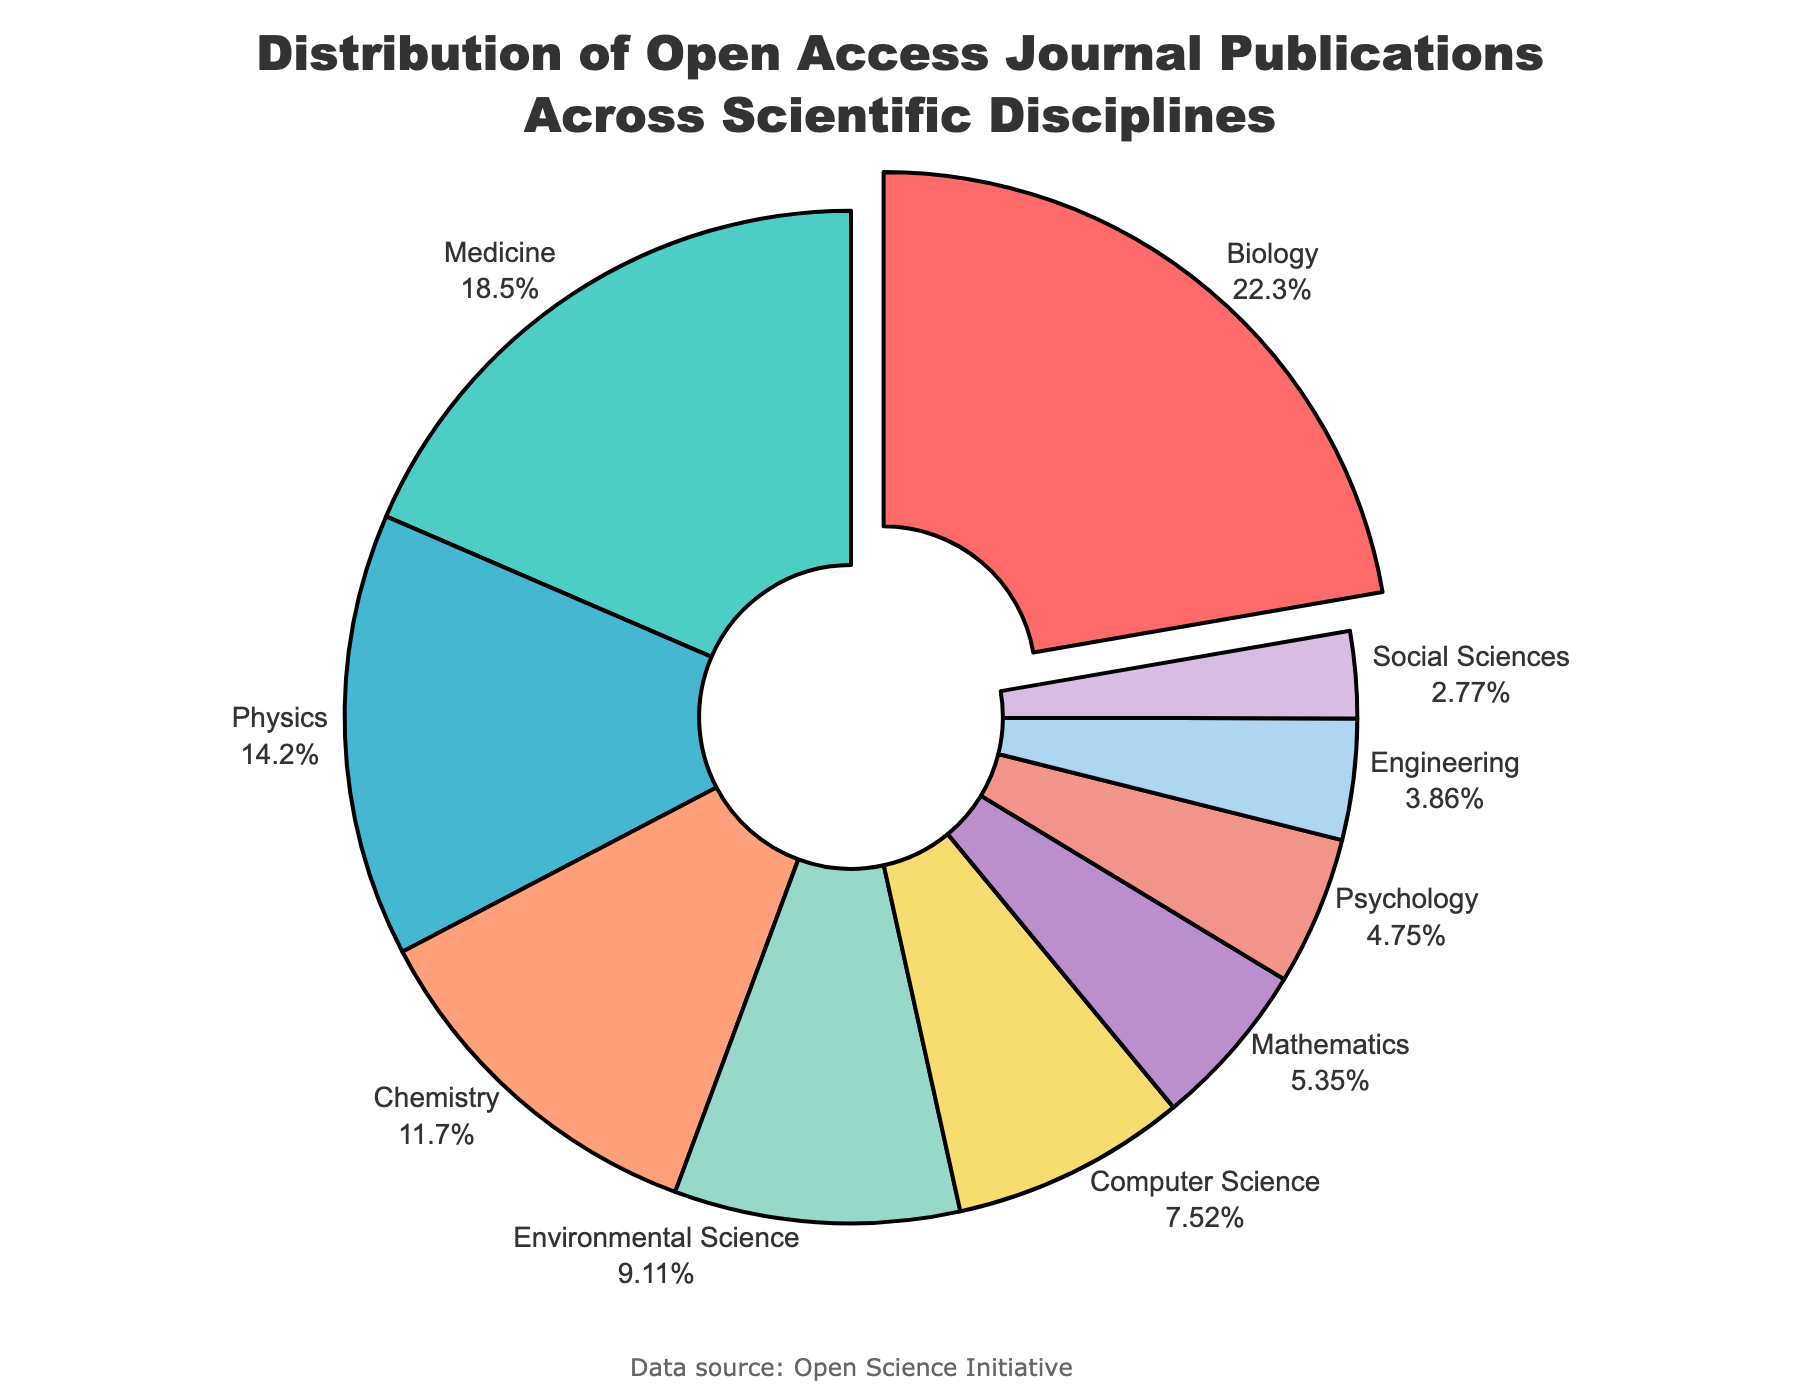What is the percentage of publications in Biology? Look at the slice labeled "Biology" and the percentage value next to it.
Answer: 22.5% Which discipline has the second highest percentage of publications? First, identify the largest slice which is for Biology at 22.5%. Then look for the next largest slice, which is Medicine at 18.7%.
Answer: Medicine What is the total percentage of publications in Medicine, Chemistry, and Environmental Science combined? Sum the percentages of Medicine (18.7%), Chemistry (11.8%), and Environmental Science (9.2%). The total is 18.7 + 11.8 + 9.2 = 39.7%.
Answer: 39.7% Which discipline contributes less to the percentage of publications, Psychology or Mathematics? Compare the percentages of Psychology (4.8%) and Mathematics (5.4%). Psychology has a smaller percentage than Mathematics.
Answer: Psychology How much more is the percentage of publications in Physics compared to Engineering? Subtract the percentage of Engineering (3.9%) from the percentage of Physics (14.3%). The difference is 14.3 - 3.9 = 10.4%.
Answer: 10.4% Which discipline has the smallest percentage of publications, and what is the color of its slice in the chart? Look for the smallest slice in the chart, which is labeled "Social Sciences" with 2.8%. The color of the slice is the last color in the legend, being a light purple.
Answer: Social Sciences, light purple Calculate the average percentage of publications across Biology, Medicine, and Physics. Sum the percentages of Biology (22.5%), Medicine (18.7%), and Physics (14.3%), and then divide by 3. The calculation is (22.5 + 18.7 + 14.3) / 3 = 18.5%.
Answer: 18.5% What percentage of publications do disciplines outside the top three (Biology, Medicine, and Physics) contribute? Subtract the sum of the top three percentages (Biology 22.5%, Medicine 18.7%, Physics 14.3%) from 100%. The sum is 22.5 + 18.7 + 14.3 = 55.5%. The remaining percentage is 100 - 55.5 = 44.5%.
Answer: 44.5% Which discipline's slice is visually pulled out from the pie chart and why? Identify the slice that is visually pulled out, which is the largest slice (Biology 22.5%), to highlight its significance.
Answer: Biology, because it has the highest percentage What is the difference in percentage between the highest and lowest represented disciplines? Subtract the percentage of the lowest represented discipline (Social Sciences 2.8%) from the highest (Biology 22.5%). The difference is 22.5 - 2.8 = 19.7%.
Answer: 19.7% 